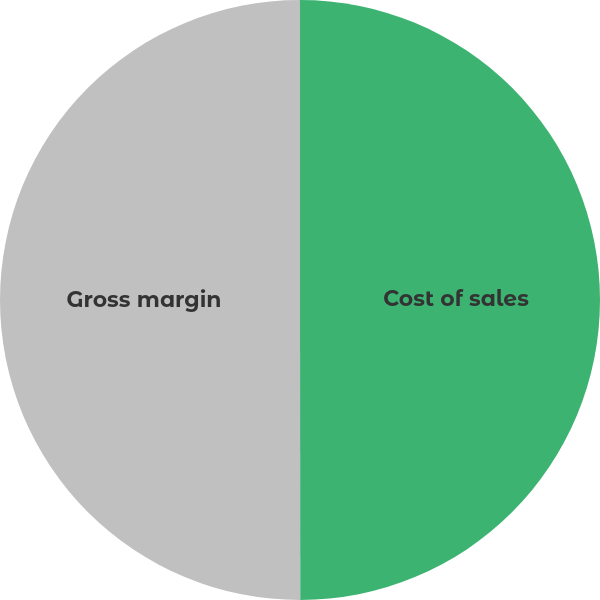Convert chart to OTSL. <chart><loc_0><loc_0><loc_500><loc_500><pie_chart><fcel>Cost of sales<fcel>Gross margin<nl><fcel>49.99%<fcel>50.01%<nl></chart> 